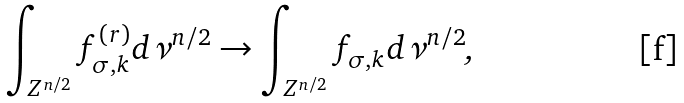Convert formula to latex. <formula><loc_0><loc_0><loc_500><loc_500>\int _ { Z ^ { n / 2 } } f _ { \sigma , k } ^ { \left ( r \right ) } d \nu ^ { n / 2 } \rightarrow \int _ { Z ^ { n / 2 } } f _ { \sigma , k } d \nu ^ { n / 2 } \text {,}</formula> 